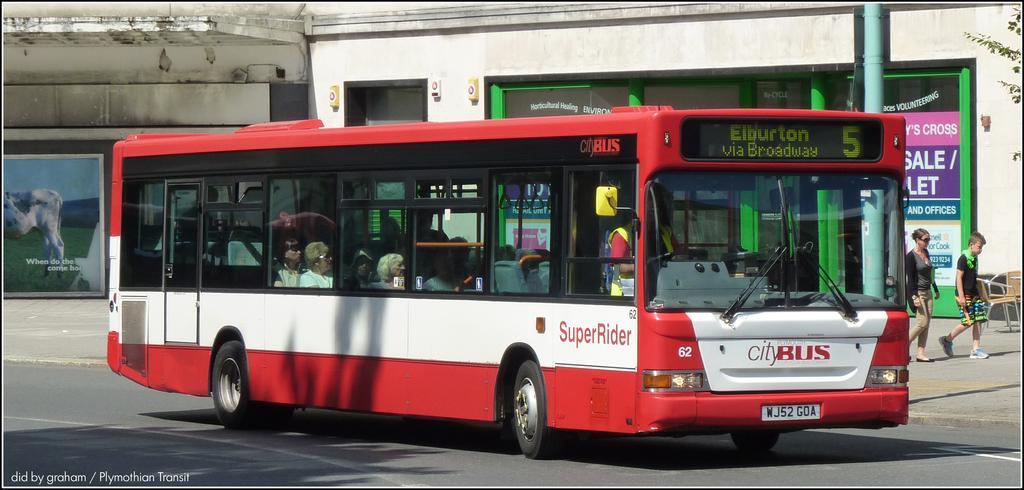Could you give a brief overview of what you see in this image? There are people inside a bus and there are two people walking. We can see road and boards on pole. In the background we can see posters,walls,chairs and leaves. In the bottom left side of the image we can see text. 